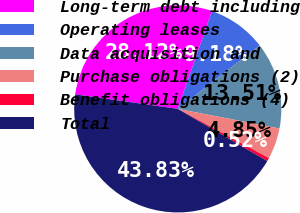Convert chart to OTSL. <chart><loc_0><loc_0><loc_500><loc_500><pie_chart><fcel>Long-term debt including<fcel>Operating leases<fcel>Data acquisition and<fcel>Purchase obligations (2)<fcel>Benefit obligations (4)<fcel>Total<nl><fcel>28.12%<fcel>9.18%<fcel>13.51%<fcel>4.85%<fcel>0.52%<fcel>43.83%<nl></chart> 